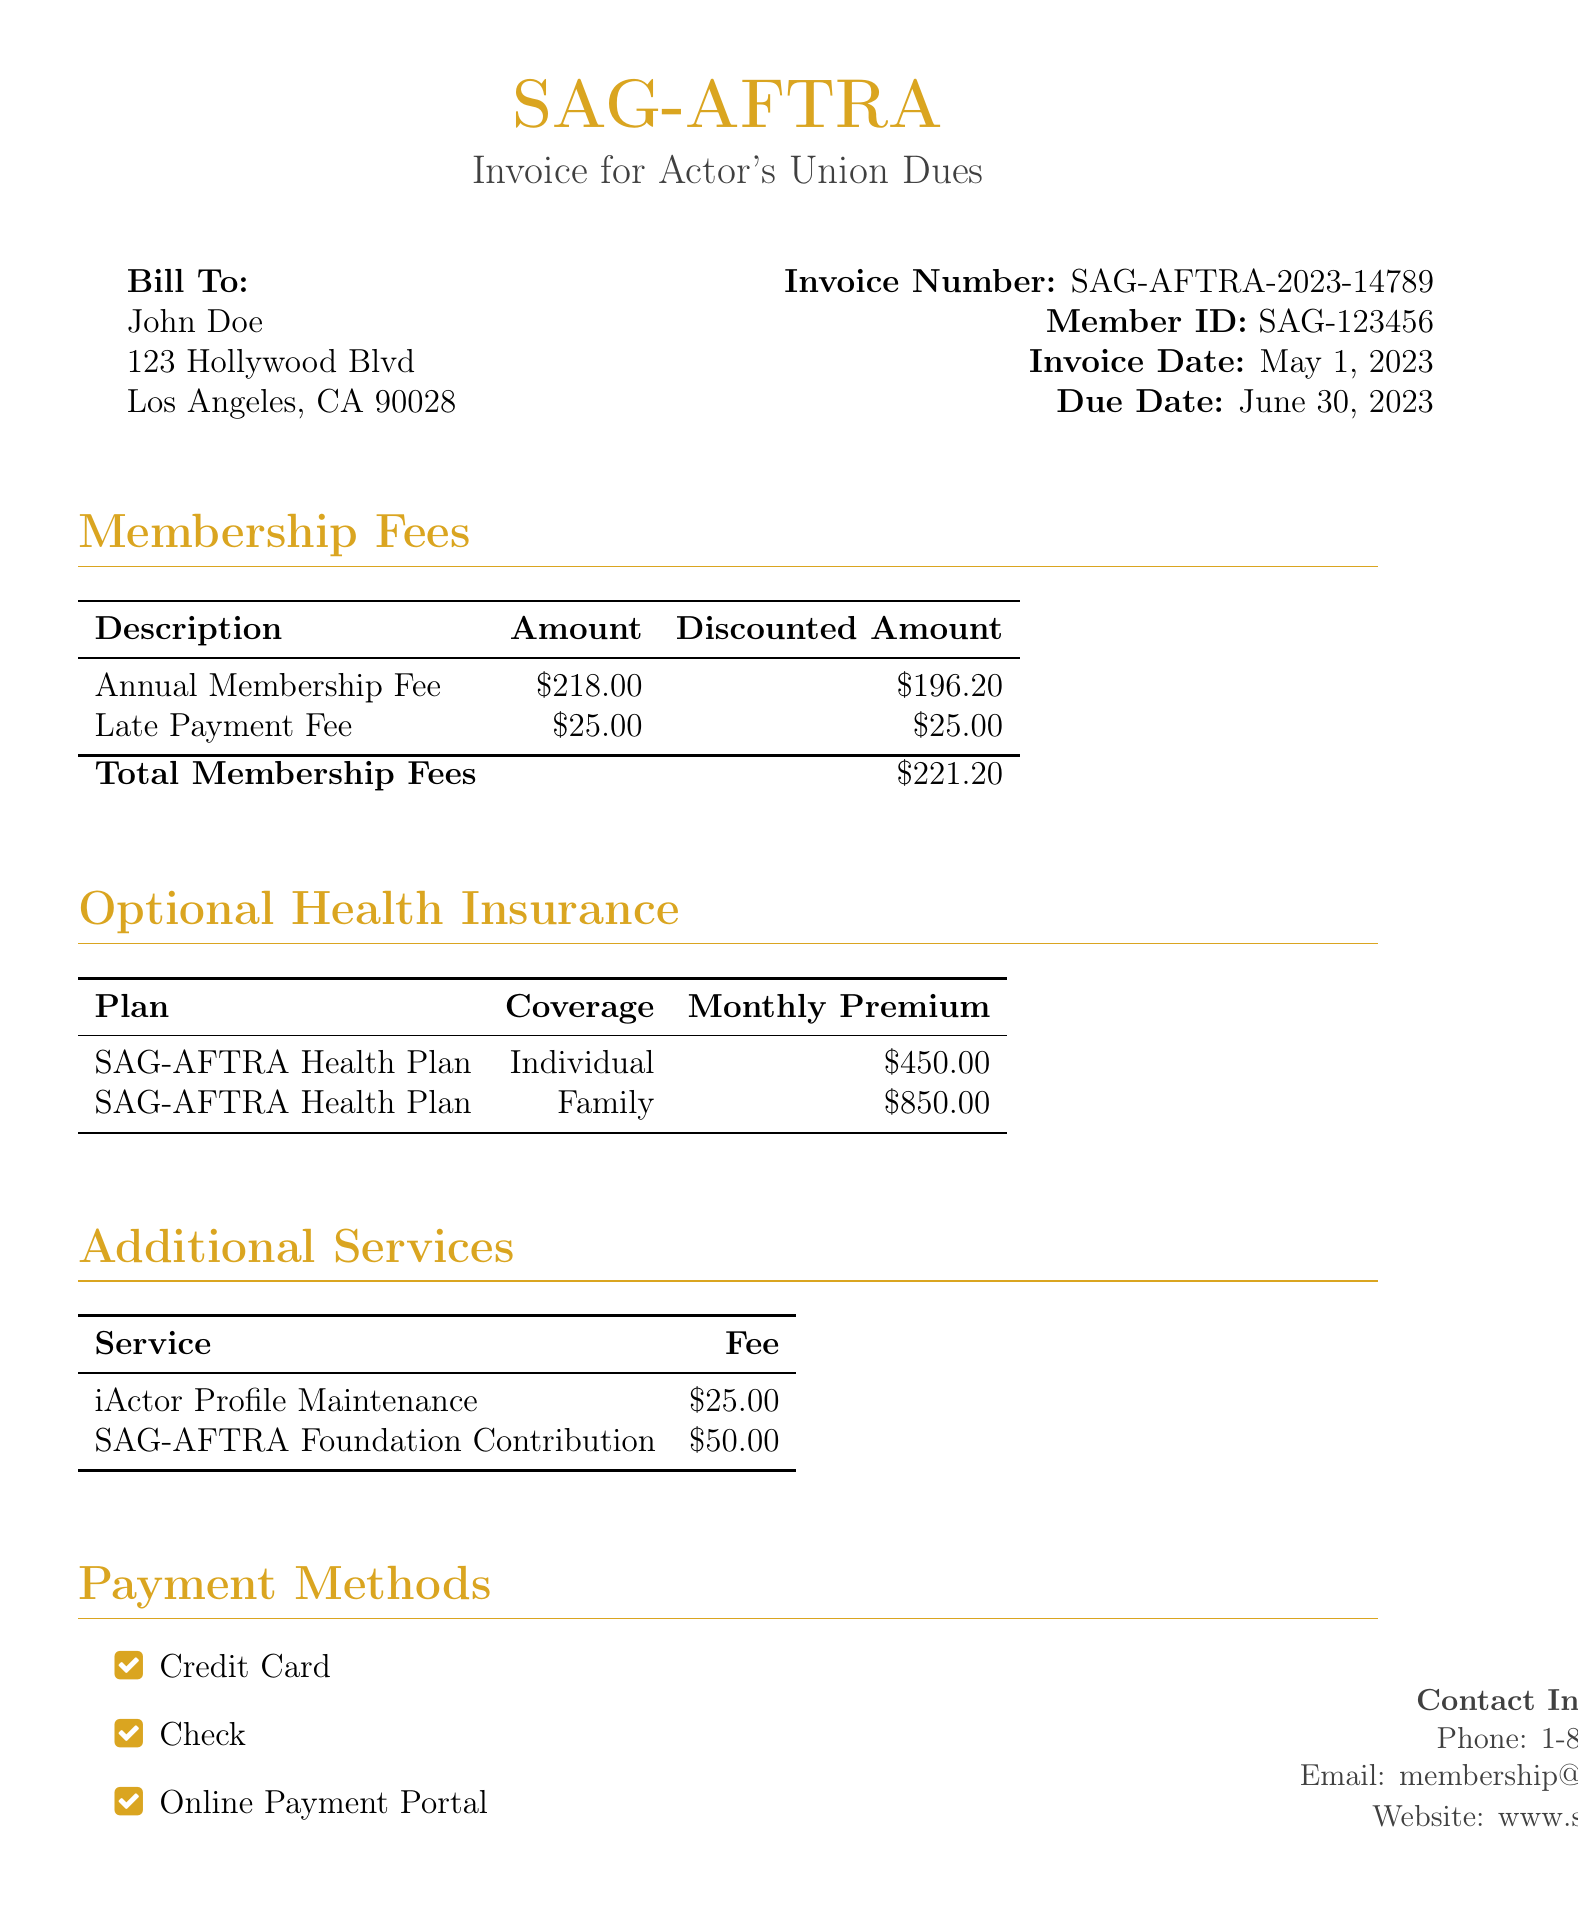What is the member ID? The member ID can be found in the header section of the document, which states "Member ID: SAG-123456".
Answer: SAG-123456 What is the total membership fees? The total membership fees are calculated from the "Total Membership Fees" row in the Membership Fees section, which shows "$221.20".
Answer: $221.20 What is the due date for the invoice? The due date is mentioned in the header section of the document as "Due Date: June 30, 2023".
Answer: June 30, 2023 How much is the annual membership fee? The annual membership fee is listed in the Membership Fees table under "Annual Membership Fee," which states "$218.00".
Answer: $218.00 What is the monthly premium for the family health plan? This can be found in the Optional Health Insurance table under "Family", which says "$850.00".
Answer: $850.00 What additional service has a fee of $50.00? The document specifies that "SAG-AFTRA Foundation Contribution" has a fee of "$50.00".
Answer: SAG-AFTRA Foundation Contribution Are late payments subject to a fee? The document explicitly lists "Late Payment Fee" in the Membership Fees section, indicating that there is a fee for late payments.
Answer: Yes What discount is applied to the annual membership fee? The document highlights that a "10% discount" is applied to the annual membership fee.
Answer: 10% What payment methods are available? The available payment methods are listed at the bottom of the document as credit card, check, and online payment portal.
Answer: Credit Card, Check, Online Payment Portal 